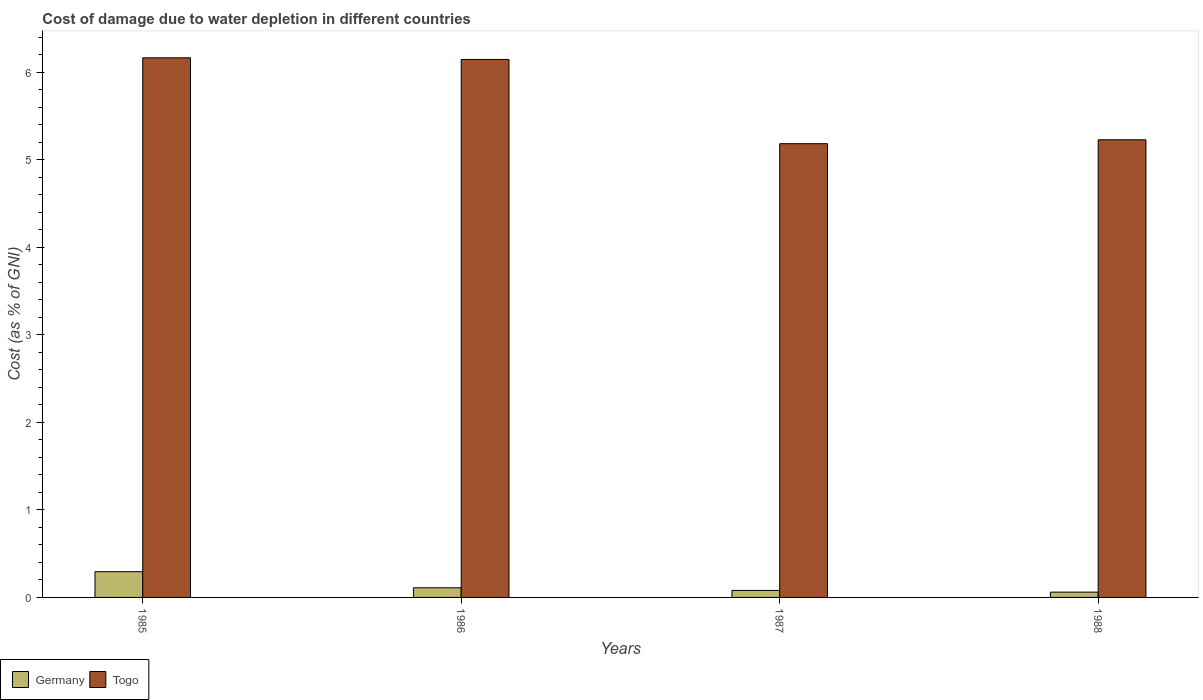How many different coloured bars are there?
Offer a terse response. 2. How many groups of bars are there?
Offer a terse response. 4. Are the number of bars on each tick of the X-axis equal?
Your answer should be compact. Yes. How many bars are there on the 4th tick from the right?
Your answer should be very brief. 2. In how many cases, is the number of bars for a given year not equal to the number of legend labels?
Ensure brevity in your answer.  0. What is the cost of damage caused due to water depletion in Togo in 1987?
Make the answer very short. 5.18. Across all years, what is the maximum cost of damage caused due to water depletion in Togo?
Your answer should be very brief. 6.16. Across all years, what is the minimum cost of damage caused due to water depletion in Germany?
Give a very brief answer. 0.06. What is the total cost of damage caused due to water depletion in Togo in the graph?
Give a very brief answer. 22.72. What is the difference between the cost of damage caused due to water depletion in Germany in 1985 and that in 1987?
Give a very brief answer. 0.21. What is the difference between the cost of damage caused due to water depletion in Togo in 1988 and the cost of damage caused due to water depletion in Germany in 1985?
Offer a very short reply. 4.93. What is the average cost of damage caused due to water depletion in Germany per year?
Provide a succinct answer. 0.14. In the year 1986, what is the difference between the cost of damage caused due to water depletion in Togo and cost of damage caused due to water depletion in Germany?
Give a very brief answer. 6.03. In how many years, is the cost of damage caused due to water depletion in Germany greater than 1.2 %?
Offer a terse response. 0. What is the ratio of the cost of damage caused due to water depletion in Togo in 1986 to that in 1988?
Offer a very short reply. 1.18. Is the difference between the cost of damage caused due to water depletion in Togo in 1987 and 1988 greater than the difference between the cost of damage caused due to water depletion in Germany in 1987 and 1988?
Provide a short and direct response. No. What is the difference between the highest and the second highest cost of damage caused due to water depletion in Togo?
Provide a succinct answer. 0.02. What is the difference between the highest and the lowest cost of damage caused due to water depletion in Togo?
Offer a very short reply. 0.98. What does the 2nd bar from the left in 1985 represents?
Make the answer very short. Togo. What does the 2nd bar from the right in 1985 represents?
Your answer should be very brief. Germany. How many bars are there?
Keep it short and to the point. 8. Are all the bars in the graph horizontal?
Ensure brevity in your answer.  No. What is the difference between two consecutive major ticks on the Y-axis?
Provide a short and direct response. 1. Are the values on the major ticks of Y-axis written in scientific E-notation?
Ensure brevity in your answer.  No. Does the graph contain any zero values?
Your response must be concise. No. Does the graph contain grids?
Keep it short and to the point. No. How many legend labels are there?
Offer a terse response. 2. How are the legend labels stacked?
Ensure brevity in your answer.  Horizontal. What is the title of the graph?
Provide a short and direct response. Cost of damage due to water depletion in different countries. Does "Bahrain" appear as one of the legend labels in the graph?
Your answer should be very brief. No. What is the label or title of the X-axis?
Ensure brevity in your answer.  Years. What is the label or title of the Y-axis?
Make the answer very short. Cost (as % of GNI). What is the Cost (as % of GNI) of Germany in 1985?
Your answer should be very brief. 0.29. What is the Cost (as % of GNI) of Togo in 1985?
Your answer should be very brief. 6.16. What is the Cost (as % of GNI) in Germany in 1986?
Provide a short and direct response. 0.11. What is the Cost (as % of GNI) in Togo in 1986?
Offer a terse response. 6.14. What is the Cost (as % of GNI) in Germany in 1987?
Give a very brief answer. 0.08. What is the Cost (as % of GNI) in Togo in 1987?
Your response must be concise. 5.18. What is the Cost (as % of GNI) in Germany in 1988?
Offer a terse response. 0.06. What is the Cost (as % of GNI) in Togo in 1988?
Offer a terse response. 5.23. Across all years, what is the maximum Cost (as % of GNI) of Germany?
Your response must be concise. 0.29. Across all years, what is the maximum Cost (as % of GNI) in Togo?
Ensure brevity in your answer.  6.16. Across all years, what is the minimum Cost (as % of GNI) in Germany?
Provide a succinct answer. 0.06. Across all years, what is the minimum Cost (as % of GNI) in Togo?
Offer a terse response. 5.18. What is the total Cost (as % of GNI) in Germany in the graph?
Give a very brief answer. 0.54. What is the total Cost (as % of GNI) of Togo in the graph?
Give a very brief answer. 22.72. What is the difference between the Cost (as % of GNI) in Germany in 1985 and that in 1986?
Make the answer very short. 0.18. What is the difference between the Cost (as % of GNI) in Togo in 1985 and that in 1986?
Ensure brevity in your answer.  0.02. What is the difference between the Cost (as % of GNI) of Germany in 1985 and that in 1987?
Provide a short and direct response. 0.21. What is the difference between the Cost (as % of GNI) in Togo in 1985 and that in 1987?
Your response must be concise. 0.98. What is the difference between the Cost (as % of GNI) of Germany in 1985 and that in 1988?
Give a very brief answer. 0.23. What is the difference between the Cost (as % of GNI) in Togo in 1985 and that in 1988?
Your answer should be compact. 0.94. What is the difference between the Cost (as % of GNI) in Germany in 1986 and that in 1988?
Offer a terse response. 0.05. What is the difference between the Cost (as % of GNI) of Togo in 1986 and that in 1988?
Your answer should be compact. 0.92. What is the difference between the Cost (as % of GNI) in Germany in 1987 and that in 1988?
Ensure brevity in your answer.  0.02. What is the difference between the Cost (as % of GNI) in Togo in 1987 and that in 1988?
Give a very brief answer. -0.04. What is the difference between the Cost (as % of GNI) in Germany in 1985 and the Cost (as % of GNI) in Togo in 1986?
Keep it short and to the point. -5.85. What is the difference between the Cost (as % of GNI) of Germany in 1985 and the Cost (as % of GNI) of Togo in 1987?
Provide a short and direct response. -4.89. What is the difference between the Cost (as % of GNI) in Germany in 1985 and the Cost (as % of GNI) in Togo in 1988?
Your answer should be compact. -4.93. What is the difference between the Cost (as % of GNI) of Germany in 1986 and the Cost (as % of GNI) of Togo in 1987?
Your response must be concise. -5.07. What is the difference between the Cost (as % of GNI) in Germany in 1986 and the Cost (as % of GNI) in Togo in 1988?
Offer a terse response. -5.12. What is the difference between the Cost (as % of GNI) of Germany in 1987 and the Cost (as % of GNI) of Togo in 1988?
Keep it short and to the point. -5.15. What is the average Cost (as % of GNI) in Germany per year?
Offer a very short reply. 0.14. What is the average Cost (as % of GNI) in Togo per year?
Provide a succinct answer. 5.68. In the year 1985, what is the difference between the Cost (as % of GNI) in Germany and Cost (as % of GNI) in Togo?
Offer a terse response. -5.87. In the year 1986, what is the difference between the Cost (as % of GNI) of Germany and Cost (as % of GNI) of Togo?
Your response must be concise. -6.03. In the year 1987, what is the difference between the Cost (as % of GNI) of Germany and Cost (as % of GNI) of Togo?
Ensure brevity in your answer.  -5.1. In the year 1988, what is the difference between the Cost (as % of GNI) of Germany and Cost (as % of GNI) of Togo?
Provide a short and direct response. -5.17. What is the ratio of the Cost (as % of GNI) of Germany in 1985 to that in 1986?
Keep it short and to the point. 2.67. What is the ratio of the Cost (as % of GNI) of Germany in 1985 to that in 1987?
Your response must be concise. 3.67. What is the ratio of the Cost (as % of GNI) in Togo in 1985 to that in 1987?
Make the answer very short. 1.19. What is the ratio of the Cost (as % of GNI) of Germany in 1985 to that in 1988?
Ensure brevity in your answer.  4.86. What is the ratio of the Cost (as % of GNI) of Togo in 1985 to that in 1988?
Provide a succinct answer. 1.18. What is the ratio of the Cost (as % of GNI) of Germany in 1986 to that in 1987?
Make the answer very short. 1.37. What is the ratio of the Cost (as % of GNI) of Togo in 1986 to that in 1987?
Keep it short and to the point. 1.19. What is the ratio of the Cost (as % of GNI) of Germany in 1986 to that in 1988?
Ensure brevity in your answer.  1.82. What is the ratio of the Cost (as % of GNI) of Togo in 1986 to that in 1988?
Offer a terse response. 1.18. What is the ratio of the Cost (as % of GNI) in Germany in 1987 to that in 1988?
Your answer should be very brief. 1.32. What is the difference between the highest and the second highest Cost (as % of GNI) in Germany?
Make the answer very short. 0.18. What is the difference between the highest and the second highest Cost (as % of GNI) of Togo?
Offer a terse response. 0.02. What is the difference between the highest and the lowest Cost (as % of GNI) in Germany?
Give a very brief answer. 0.23. What is the difference between the highest and the lowest Cost (as % of GNI) in Togo?
Keep it short and to the point. 0.98. 